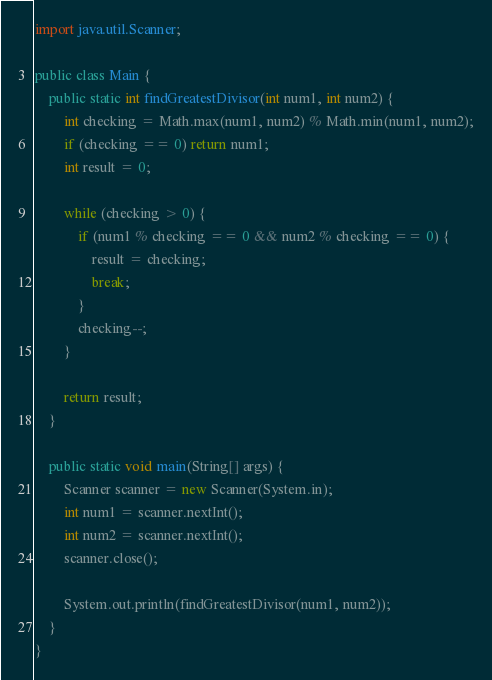<code> <loc_0><loc_0><loc_500><loc_500><_Java_>import java.util.Scanner;

public class Main {
	public static int findGreatestDivisor(int num1, int num2) {
		int checking = Math.max(num1, num2) % Math.min(num1, num2);
		if (checking == 0) return num1;
		int result = 0;
		
		while (checking > 0) {
			if (num1 % checking == 0 && num2 % checking == 0) {
				result = checking;
				break;
			}
			checking--;
		}
		
		return result;
	}
	
	public static void main(String[] args) {
		Scanner scanner = new Scanner(System.in);
		int num1 = scanner.nextInt();
		int num2 = scanner.nextInt();
		scanner.close();
		
		System.out.println(findGreatestDivisor(num1, num2));
	}
}

</code> 